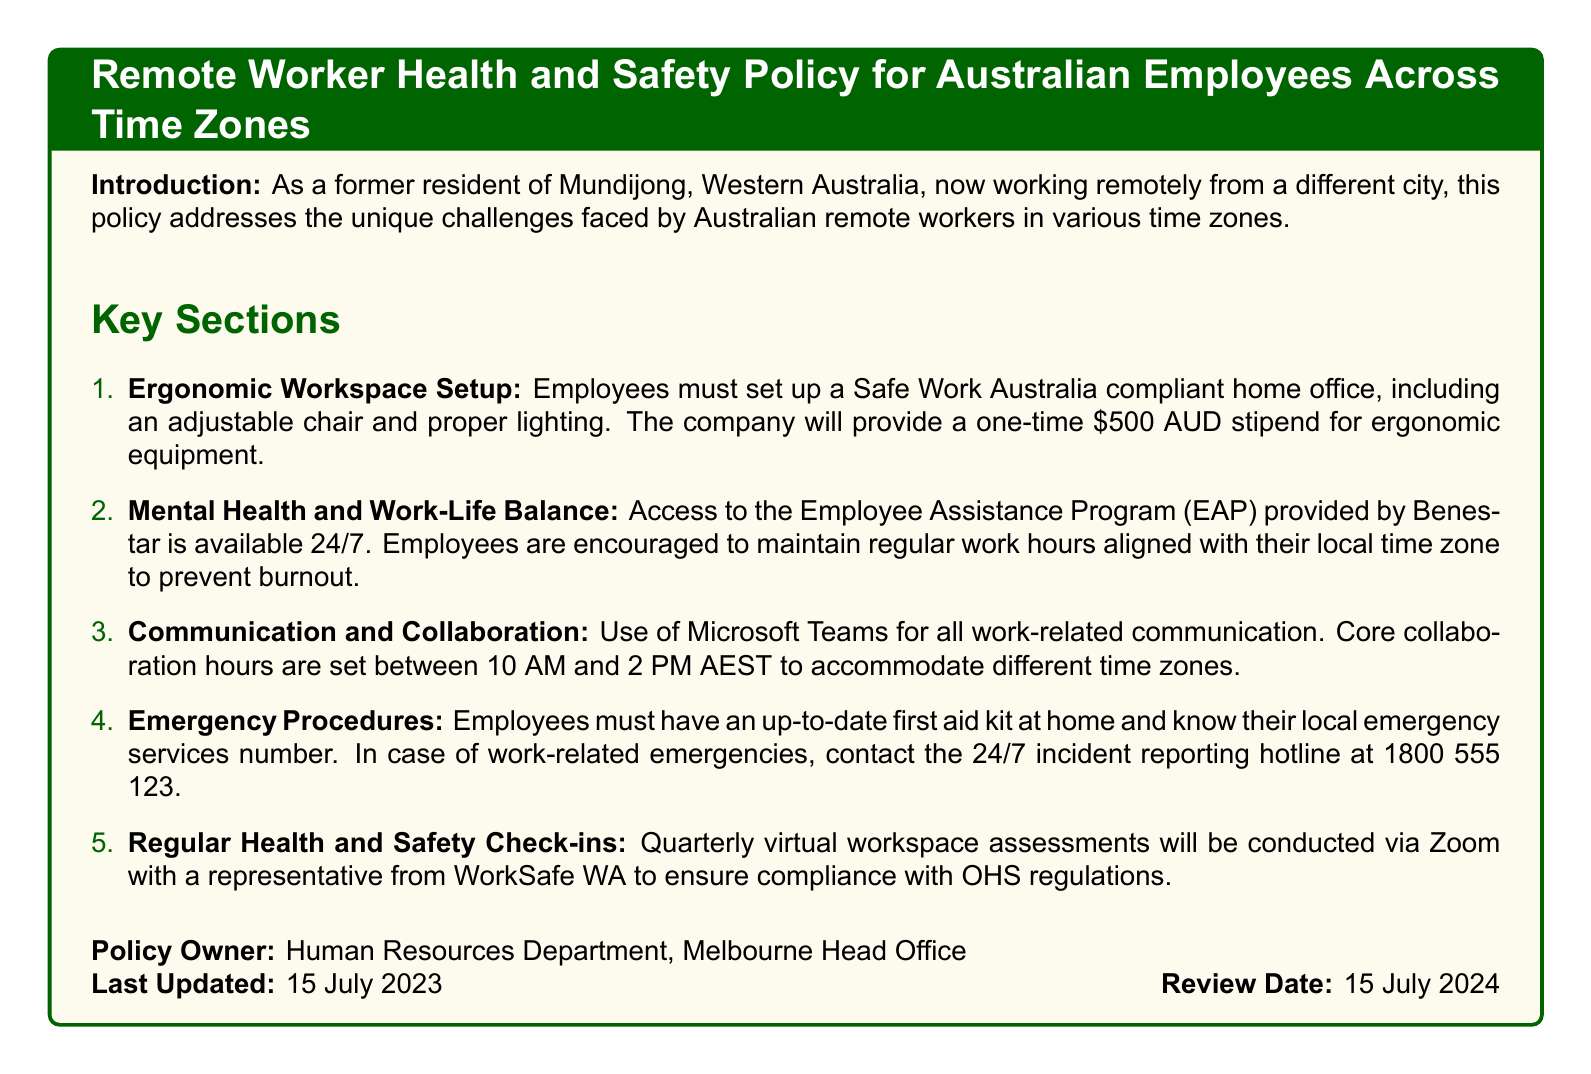what is the stipend amount for ergonomic equipment? The policy states that the company will provide a one-time stipend for ergonomic equipment.
Answer: $500 AUD what is the purpose of the Employee Assistance Program (EAP)? The policy mentions that the EAP is available 24/7 to assist with mental health and work-life balance.
Answer: Mental health support what are the core collaboration hours? The document specifies when employees should align their work hours for collaboration.
Answer: 10 AM to 2 PM AEST who should be contacted in case of work-related emergencies? The policy provides a specific hotline number for reporting emergencies.
Answer: 1800 555 123 when was the policy last updated? The document includes the date when the policy underwent its last revision.
Answer: 15 July 2023 which department owns the policy? The policy clearly states the department responsible for it.
Answer: Human Resources Department how often will health and safety check-ins be conducted? The document outlines the frequency of the virtual workspace assessments.
Answer: Quarterly what equipment must employees have in their home office? The policy lists requirements for the ergonomic workspace setup.
Answer: Adjustable chair and proper lighting what is the review date for the policy? The document mentions the date set for the next review of the policy.
Answer: 15 July 2024 